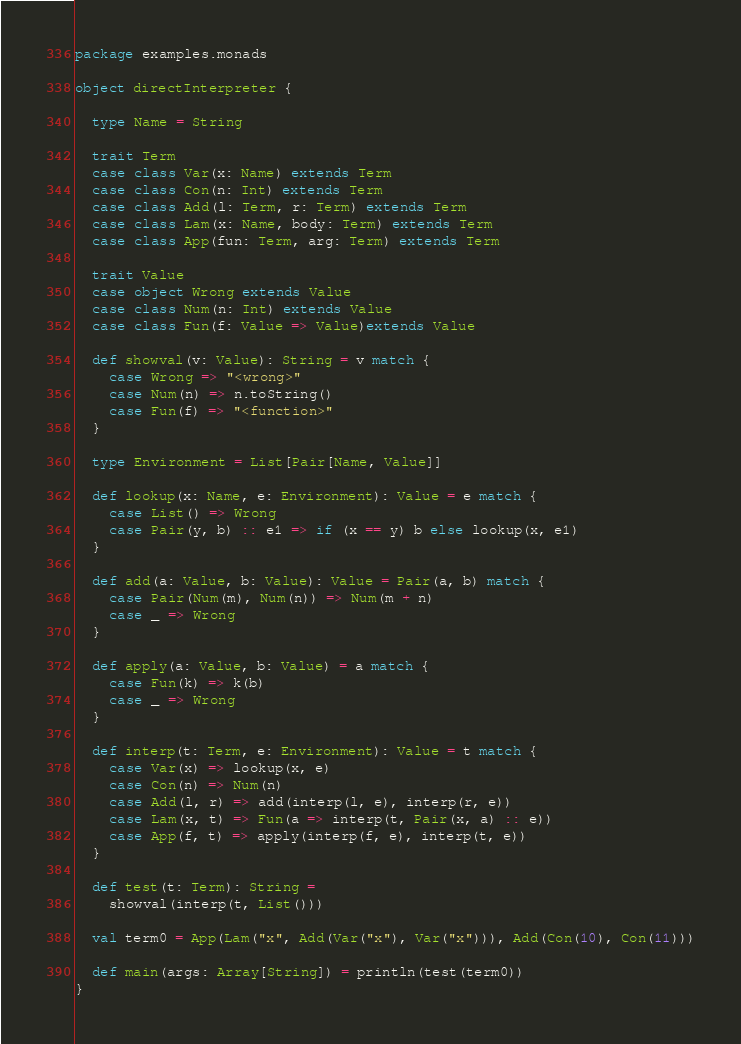<code> <loc_0><loc_0><loc_500><loc_500><_Scala_>
package examples.monads

object directInterpreter {

  type Name = String

  trait Term
  case class Var(x: Name) extends Term
  case class Con(n: Int) extends Term
  case class Add(l: Term, r: Term) extends Term
  case class Lam(x: Name, body: Term) extends Term
  case class App(fun: Term, arg: Term) extends Term

  trait Value
  case object Wrong extends Value
  case class Num(n: Int) extends Value
  case class Fun(f: Value => Value)extends Value

  def showval(v: Value): String = v match {
    case Wrong => "<wrong>"
    case Num(n) => n.toString()
    case Fun(f) => "<function>"
  }

  type Environment = List[Pair[Name, Value]]

  def lookup(x: Name, e: Environment): Value = e match {
    case List() => Wrong
    case Pair(y, b) :: e1 => if (x == y) b else lookup(x, e1)
  }

  def add(a: Value, b: Value): Value = Pair(a, b) match {
    case Pair(Num(m), Num(n)) => Num(m + n)
    case _ => Wrong
  }

  def apply(a: Value, b: Value) = a match {
    case Fun(k) => k(b)
    case _ => Wrong
  }

  def interp(t: Term, e: Environment): Value = t match {
    case Var(x) => lookup(x, e)
    case Con(n) => Num(n)
    case Add(l, r) => add(interp(l, e), interp(r, e))
    case Lam(x, t) => Fun(a => interp(t, Pair(x, a) :: e))
    case App(f, t) => apply(interp(f, e), interp(t, e))
  }

  def test(t: Term): String = 
    showval(interp(t, List()))

  val term0 = App(Lam("x", Add(Var("x"), Var("x"))), Add(Con(10), Con(11)))

  def main(args: Array[String]) = println(test(term0))
}
</code> 